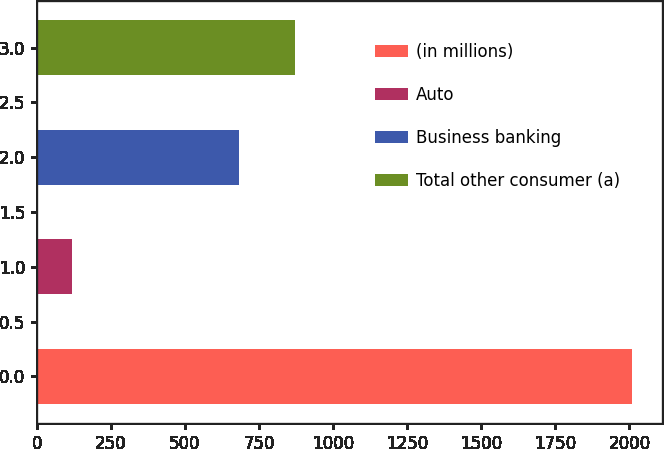<chart> <loc_0><loc_0><loc_500><loc_500><bar_chart><fcel>(in millions)<fcel>Auto<fcel>Business banking<fcel>Total other consumer (a)<nl><fcel>2010<fcel>120<fcel>682<fcel>871<nl></chart> 